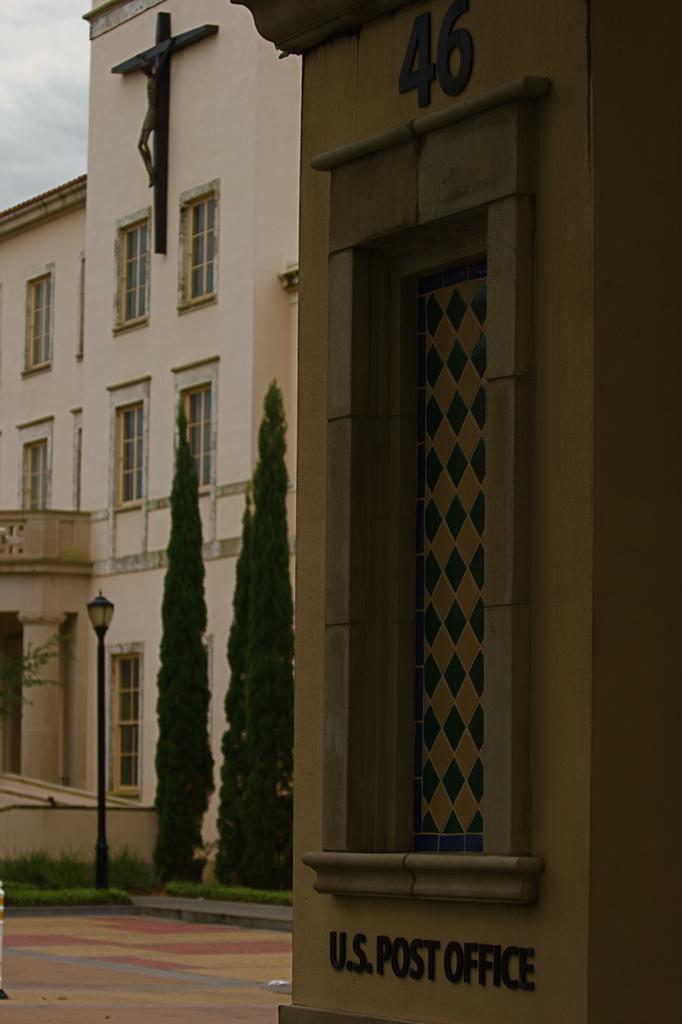Could you give a brief overview of what you see in this image? In this picture we can see buildings, windows, light pole, trees and statue. Sky is cloudy. 